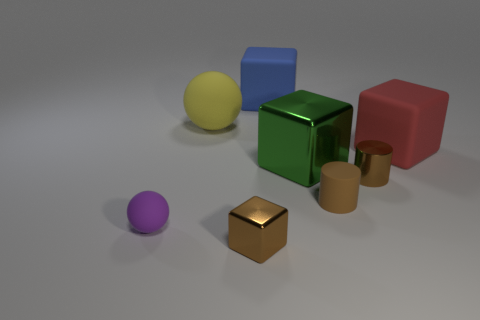Subtract 1 blocks. How many blocks are left? 3 Add 2 yellow matte balls. How many objects exist? 10 Subtract all yellow cylinders. Subtract all brown balls. How many cylinders are left? 2 Subtract all balls. How many objects are left? 6 Subtract 0 gray blocks. How many objects are left? 8 Subtract all red matte objects. Subtract all small blocks. How many objects are left? 6 Add 1 small purple rubber objects. How many small purple rubber objects are left? 2 Add 5 yellow rubber things. How many yellow rubber things exist? 6 